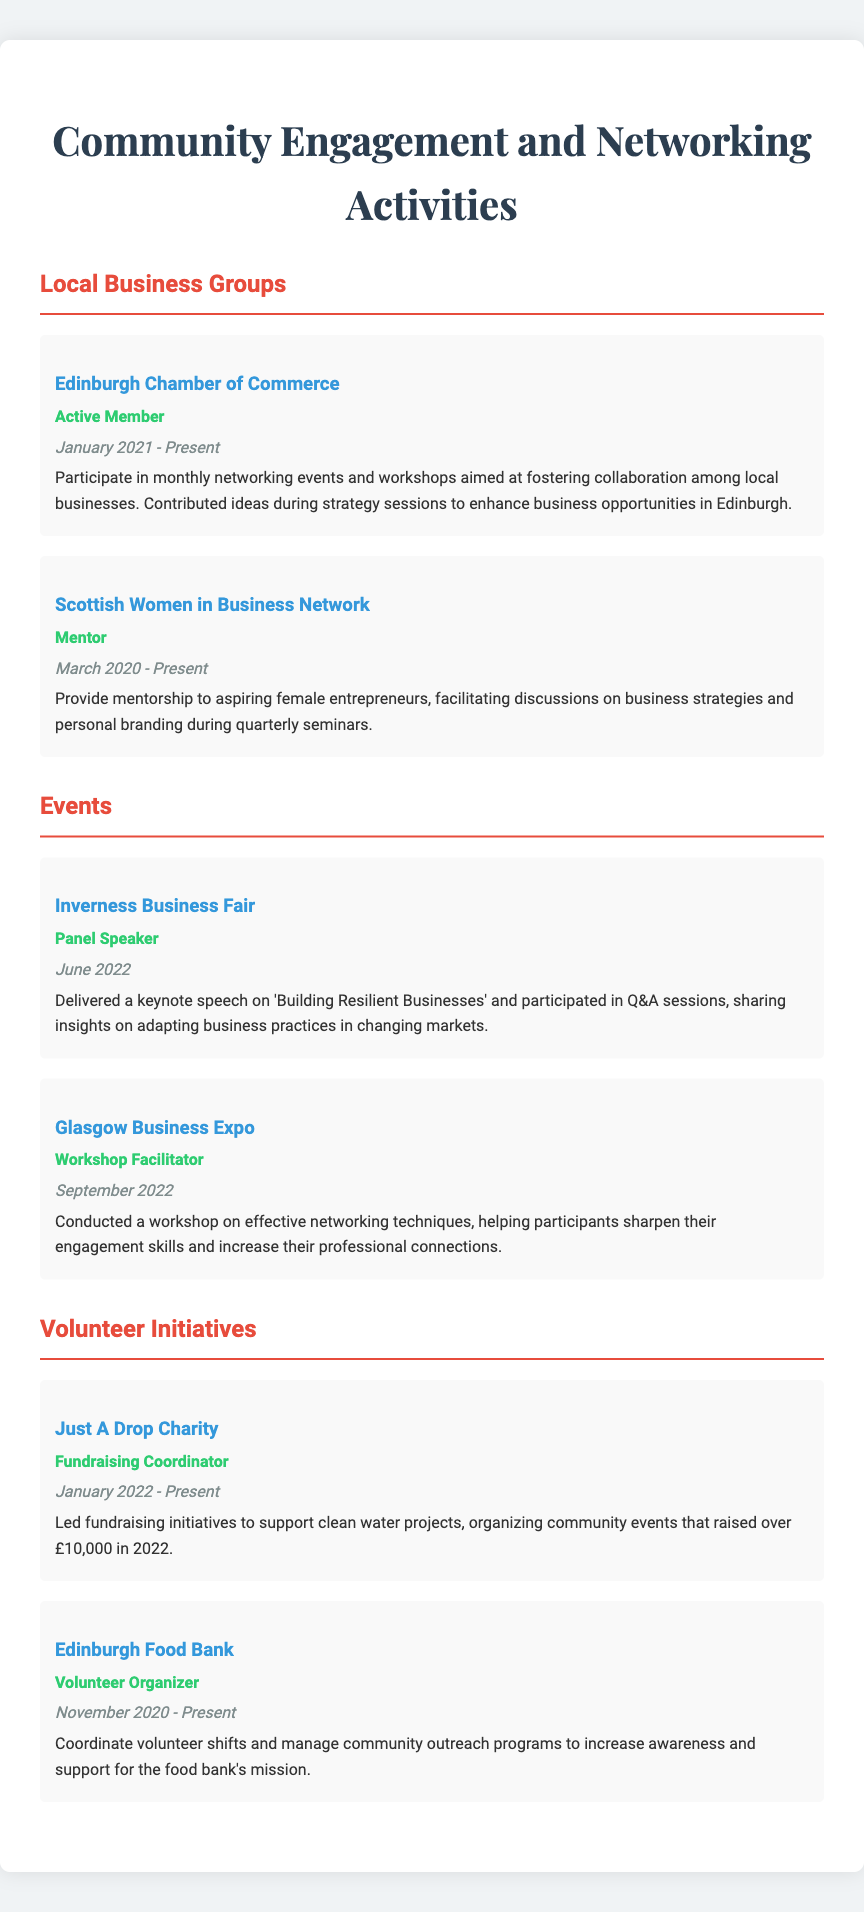What local business group has the individual been an active member of since January 2021? The document states that the individual is an active member of the Edinburgh Chamber of Commerce since January 2021.
Answer: Edinburgh Chamber of Commerce What role does the individual hold in the Scottish Women in Business Network? In the document, it is mentioned that the individual is a Mentor in the Scottish Women in Business Network.
Answer: Mentor How much money did the Just A Drop Charity raise in 2022? According to the document, over £10,000 was raised by the Just A Drop Charity in 2022.
Answer: £10,000 What was the subject of the keynote speech delivered at the Inverness Business Fair? The document reports that the keynote speech was on 'Building Resilient Businesses' at the Inverness Business Fair.
Answer: Building Resilient Businesses How long has the individual been volunteering with the Edinburgh Food Bank? The document states that the individual has been a Volunteer Organizer at the Edinburgh Food Bank since November 2020.
Answer: Since November 2020 What type of event was conducted by the individual at the Glasgow Business Expo? It is mentioned in the document that the individual conducted a workshop at the Glasgow Business Expo.
Answer: Workshop Which charity does the individual coordinate fundraising initiatives for? The document specifies that the individual coordinates fundraising initiatives for the Just A Drop Charity.
Answer: Just A Drop Charity What networking activities does participation in the Edinburgh Chamber of Commerce involve? The document describes participation as involving monthly networking events and workshops among local businesses.
Answer: Monthly networking events and workshops 